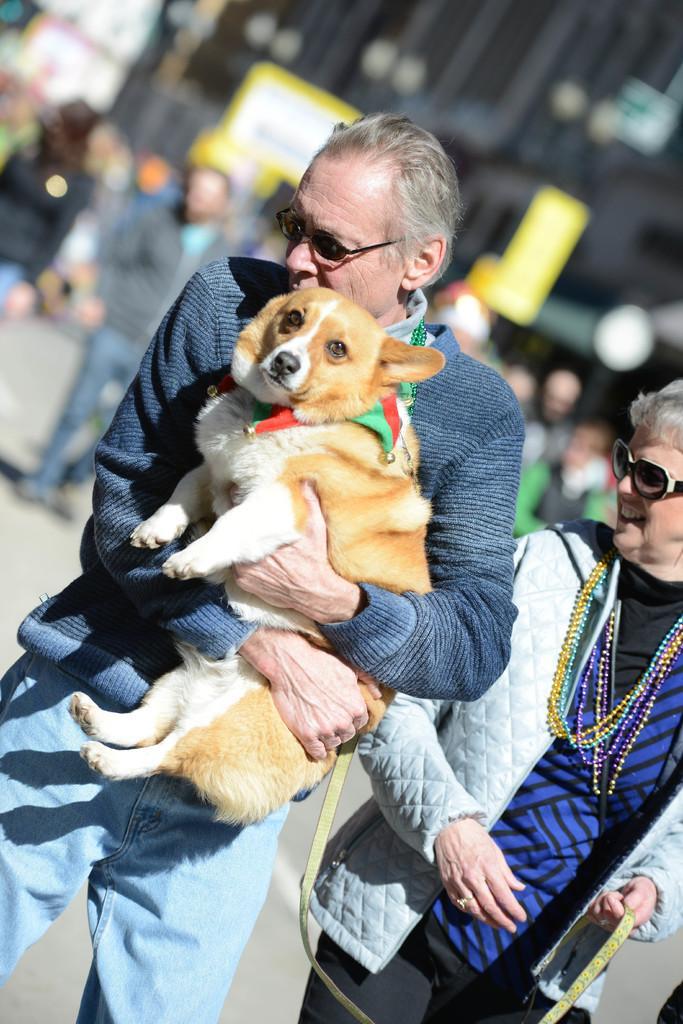Can you describe this image briefly? As we can see in the image there is a building, few people here and there and a dog. 